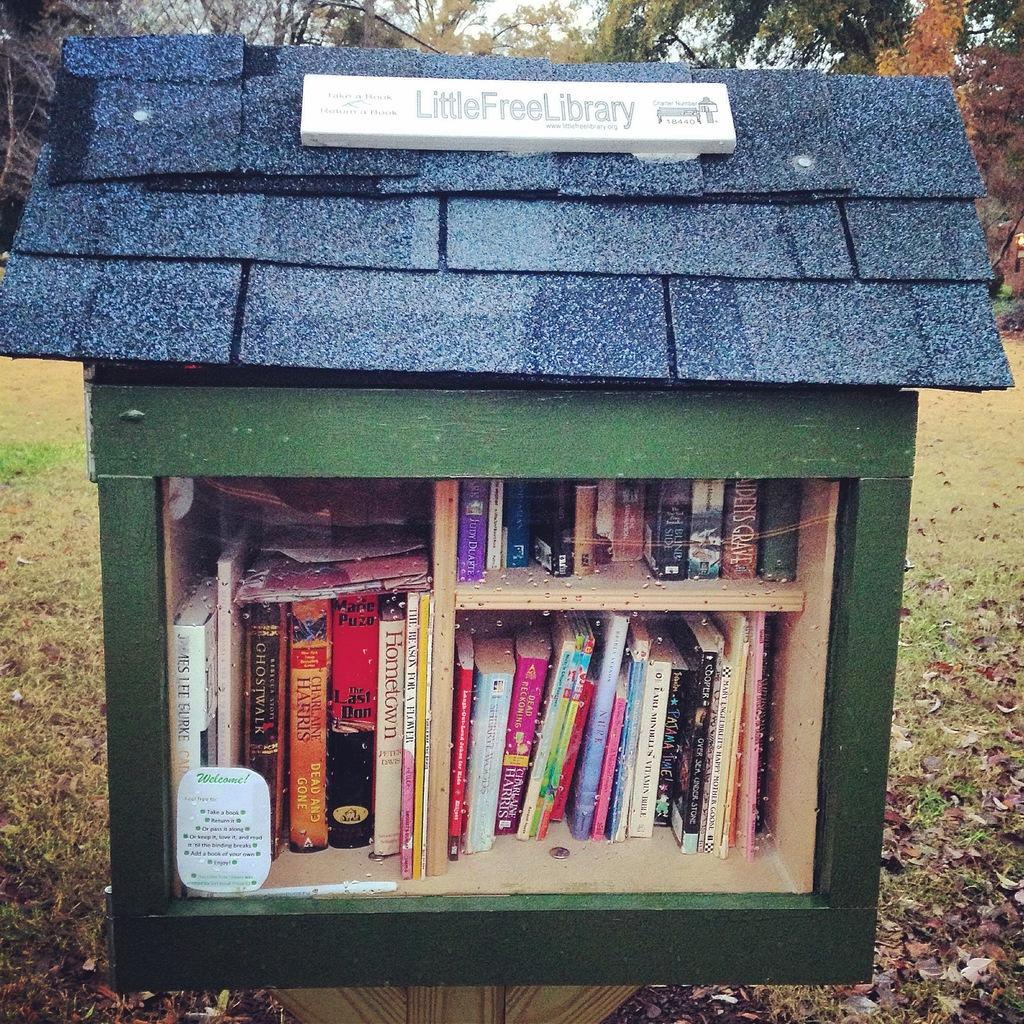What is inside the box that is visible in the image? There is a box with books in the image. What type of natural elements can be seen in the image? Trees, leaves, grass, and the sky are visible in the image. Where is the maid standing in the image? There is no maid present in the image. What type of swing can be seen in the image? There is no swing present in the image. 